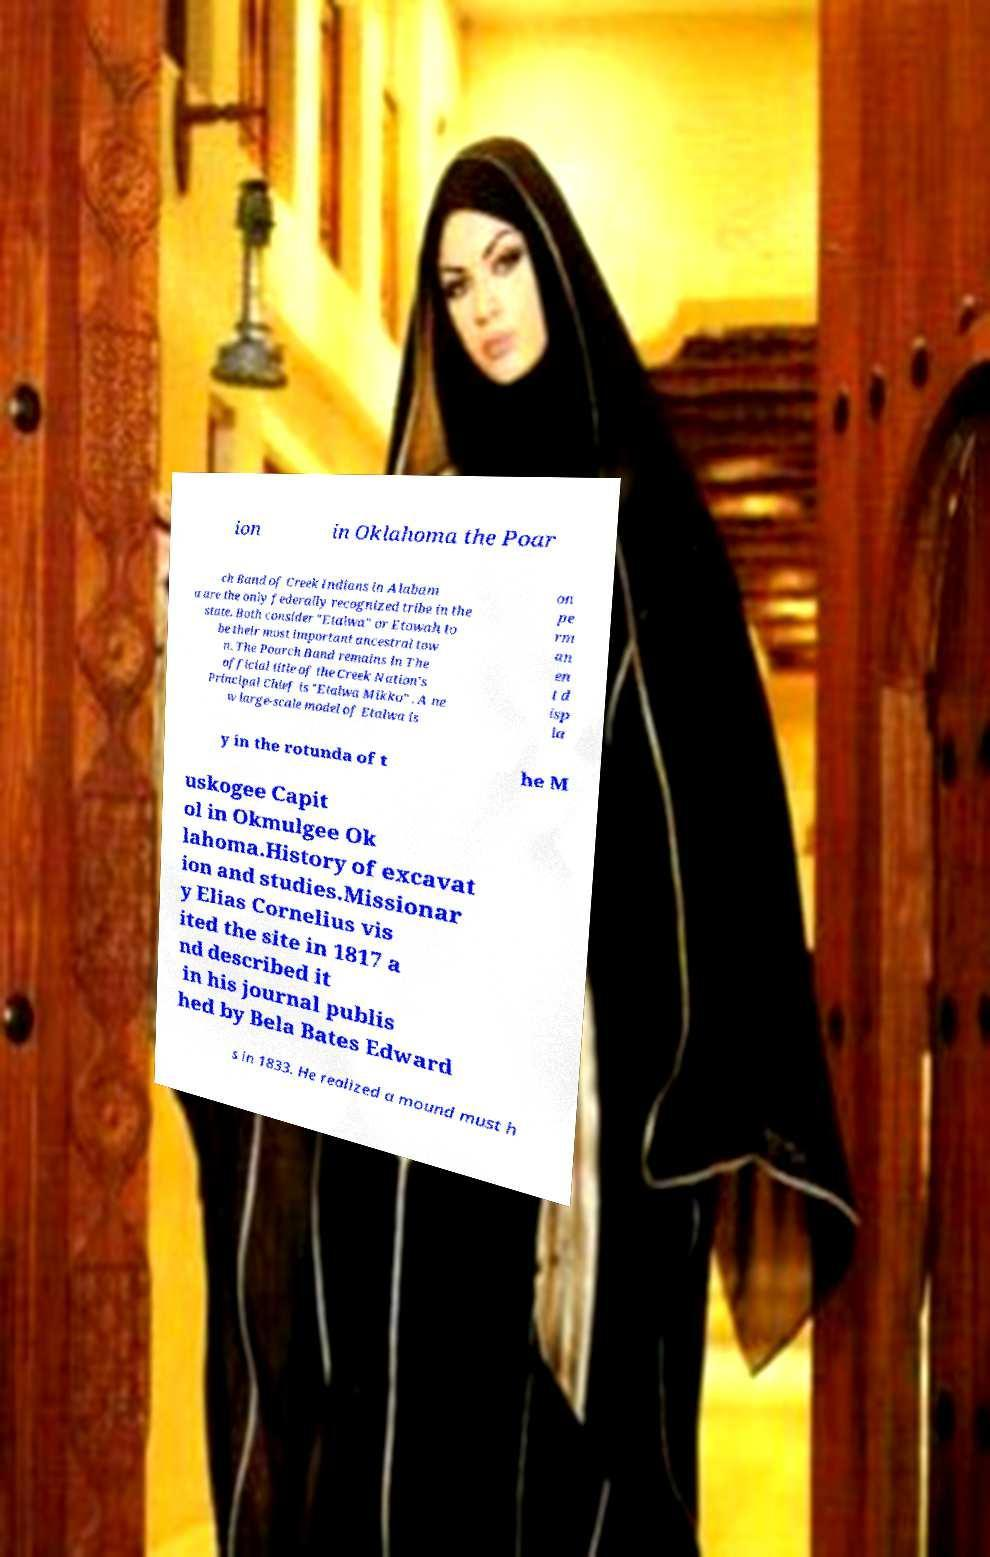Can you accurately transcribe the text from the provided image for me? ion in Oklahoma the Poar ch Band of Creek Indians in Alabam a are the only federally recognized tribe in the state. Both consider "Etalwa" or Etowah to be their most important ancestral tow n. The Poarch Band remains in The official title of the Creek Nation's Principal Chief is "Etalwa Mikko" . A ne w large-scale model of Etalwa is on pe rm an en t d isp la y in the rotunda of t he M uskogee Capit ol in Okmulgee Ok lahoma.History of excavat ion and studies.Missionar y Elias Cornelius vis ited the site in 1817 a nd described it in his journal publis hed by Bela Bates Edward s in 1833. He realized a mound must h 